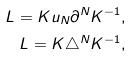Convert formula to latex. <formula><loc_0><loc_0><loc_500><loc_500>L = K u _ { N } \partial ^ { N } K ^ { - 1 } , \\ L = K \triangle ^ { N } K ^ { - 1 } ,</formula> 